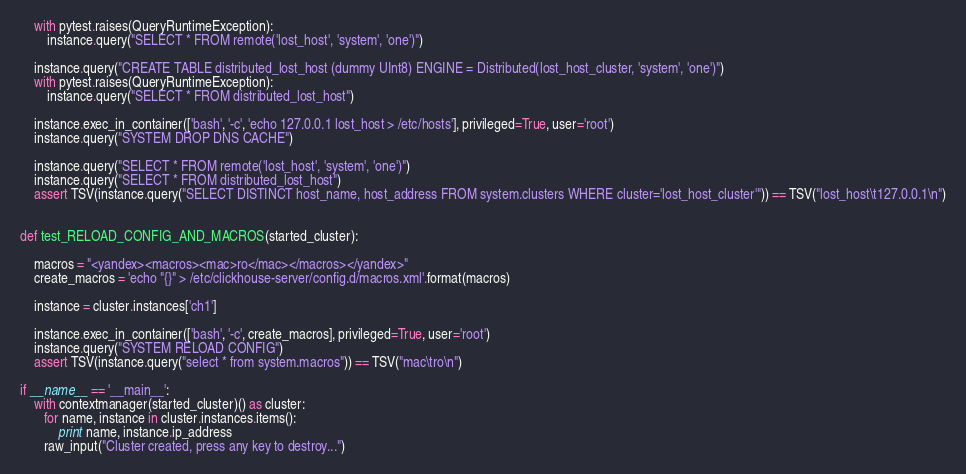<code> <loc_0><loc_0><loc_500><loc_500><_Python_>    with pytest.raises(QueryRuntimeException):
        instance.query("SELECT * FROM remote('lost_host', 'system', 'one')")

    instance.query("CREATE TABLE distributed_lost_host (dummy UInt8) ENGINE = Distributed(lost_host_cluster, 'system', 'one')")
    with pytest.raises(QueryRuntimeException):
        instance.query("SELECT * FROM distributed_lost_host")

    instance.exec_in_container(['bash', '-c', 'echo 127.0.0.1 lost_host > /etc/hosts'], privileged=True, user='root')
    instance.query("SYSTEM DROP DNS CACHE")

    instance.query("SELECT * FROM remote('lost_host', 'system', 'one')")
    instance.query("SELECT * FROM distributed_lost_host")
    assert TSV(instance.query("SELECT DISTINCT host_name, host_address FROM system.clusters WHERE cluster='lost_host_cluster'")) == TSV("lost_host\t127.0.0.1\n")


def test_RELOAD_CONFIG_AND_MACROS(started_cluster):

    macros = "<yandex><macros><mac>ro</mac></macros></yandex>"
    create_macros = 'echo "{}" > /etc/clickhouse-server/config.d/macros.xml'.format(macros)

    instance = cluster.instances['ch1']

    instance.exec_in_container(['bash', '-c', create_macros], privileged=True, user='root')
    instance.query("SYSTEM RELOAD CONFIG")
    assert TSV(instance.query("select * from system.macros")) == TSV("mac\tro\n")

if __name__ == '__main__':
    with contextmanager(started_cluster)() as cluster:
       for name, instance in cluster.instances.items():
           print name, instance.ip_address
       raw_input("Cluster created, press any key to destroy...")
</code> 